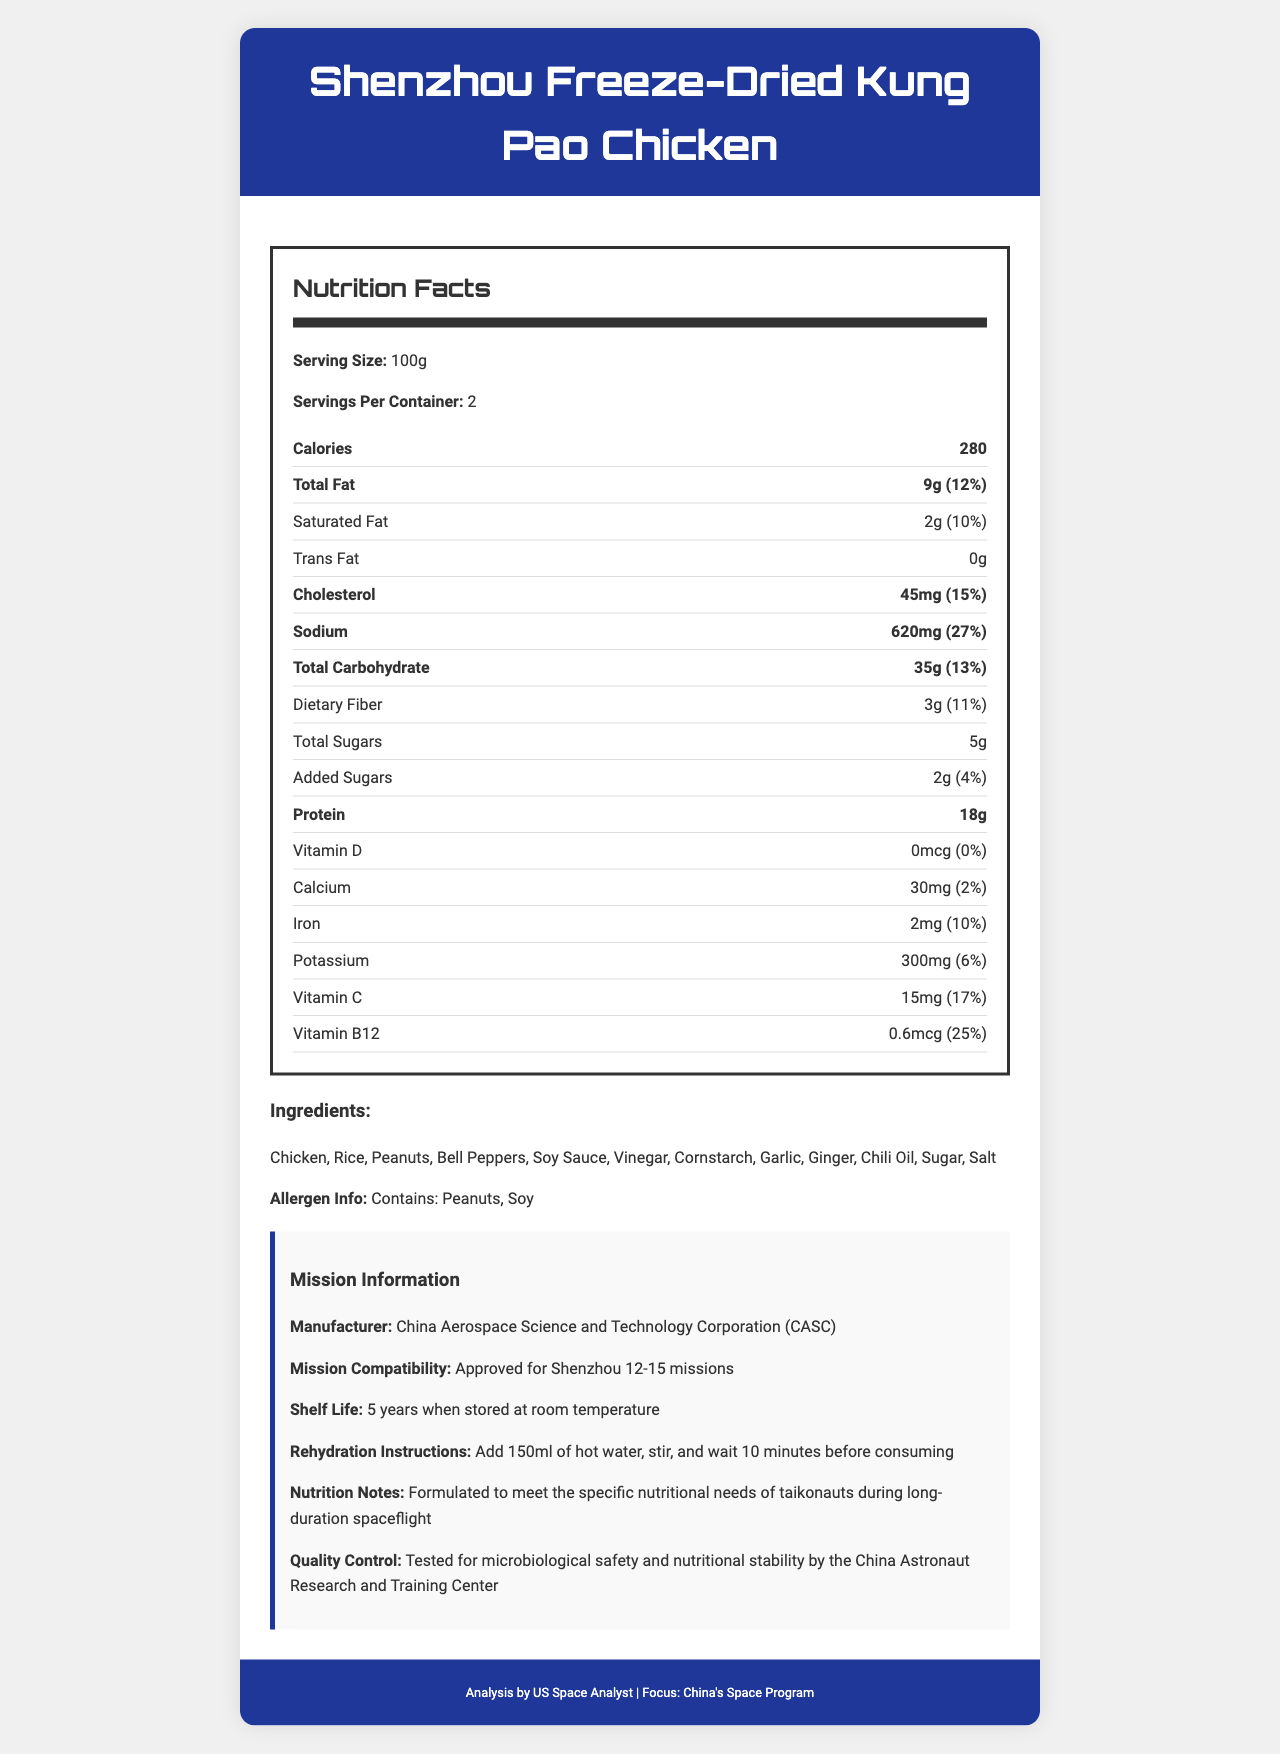what is the serving size for Shenzhou Freeze-Dried Kung Pao Chicken? The serving size is clearly mentioned in the nutrition facts section of the document as "Serving Size: 100g".
Answer: 100g how many calories are in one serving? The document states that there are 280 calories per serving.
Answer: 280 what is the total fat content per serving? The total fat content per serving is listed as 9g.
Answer: 9g what is the daily value percentage of sodium in one serving? The sodium daily value percentage is provided as 27%.
Answer: 27% what ingredients are used in this space food? The ingredients list is provided verbatim in the document under "Ingredients".
Answer: Chicken, Rice, Peanuts, Bell Peppers, Soy Sauce, Vinegar, Cornstarch, Garlic, Ginger, Chili Oil, Sugar, Salt how many grams of dietary fiber are in one serving? The dietary fiber content per serving is listed as 3g.
Answer: 3g which is the manufacturer of this space food? The document mentions the manufacturer as the China Aerospace Science and Technology Corporation (CASC).
Answer: China Aerospace Science and Technology Corporation (CASC) what is the rehydration instruction for this product? The rehydration instruction is to add 150ml of hot water, stir, and wait 10 minutes before consuming.
Answer: Add 150ml of hot water, stir, and wait 10 minutes before consuming what is the shelf life of the Shenzhou Freeze-Dried Kung Pao Chicken? The shelf life of the product is listed as 5 years when stored at room temperature.
Answer: 5 years when stored at room temperature what is the mission compatibility for this space food? A. Shenzhou 10-14 B. Shenzhou 12-15 C. Shenzhou 13-16 D. Shenzhou 11-14 The document mentions "Mission Compatibility: Approved for Shenzhou 12-15 missions."
Answer: B what is the total carbohydrate content per serving? A. 30g B. 35g C. 40g D. 25g The total carbohydrate content per serving is 35g.
Answer: B does this product contain peanuts? The allergen information section indicates that the product contains peanuts.
Answer: Yes describe the main focus of the document. The document's main focus is to provide comprehensive nutritional information and other related details about the Shenzhou Freeze-Dried Kung Pao Chicken, a space food formulated for Chinese space missions.
Answer: The document is a nutrition facts label for Shenzhou Freeze-Dried Kung Pao Chicken, a space food used in China's Shenzhou missions. It provides nutrient information, ingredients, rehydration instructions, manufacturer details, mission compatibility, shelf life, and quality control measures. does the product contain any Vitamin D? The document states that the Vitamin D content is 0mcg with a 0% daily value.
Answer: No can you determine the exact price of this product? The document does not provide any information regarding the price of the product.
Answer: Cannot be determined 